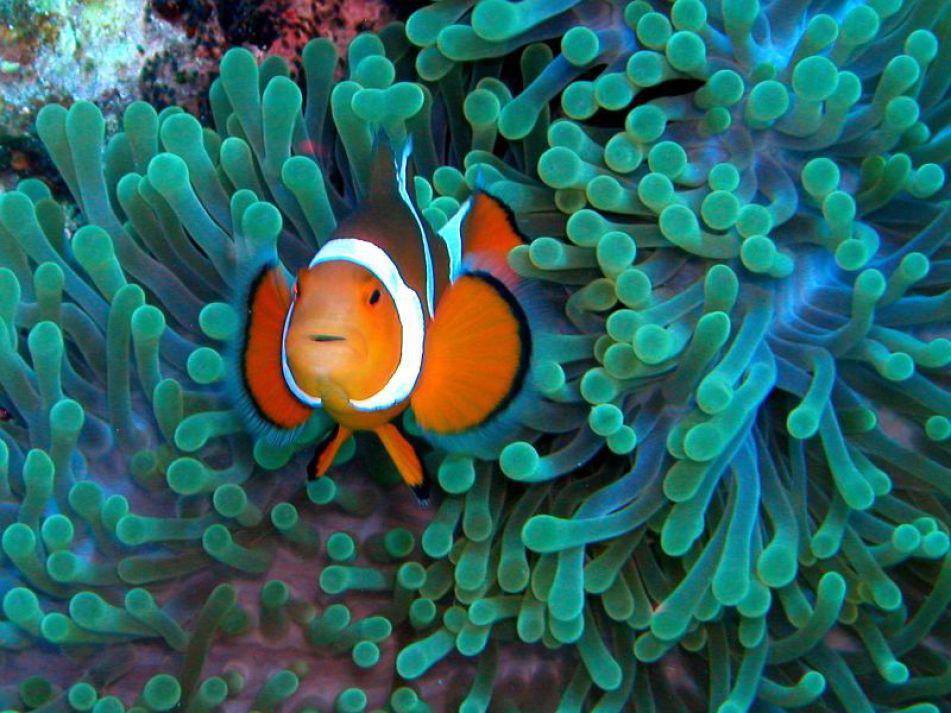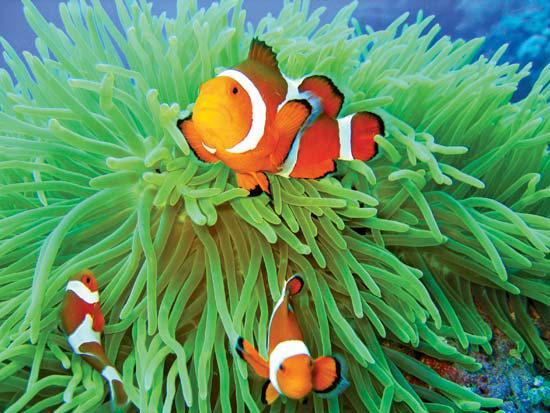The first image is the image on the left, the second image is the image on the right. Considering the images on both sides, is "An image shows an orange fish swimming amid green anemone tendrils, and the image contains multiple fish." valid? Answer yes or no. Yes. The first image is the image on the left, the second image is the image on the right. For the images displayed, is the sentence "There are two or fewer fish across both images." factually correct? Answer yes or no. No. 